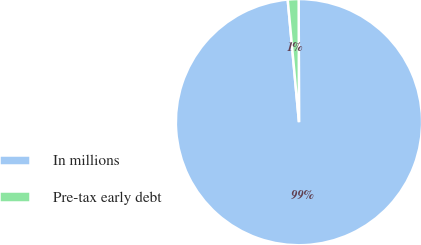Convert chart. <chart><loc_0><loc_0><loc_500><loc_500><pie_chart><fcel>In millions<fcel>Pre-tax early debt<nl><fcel>98.58%<fcel>1.42%<nl></chart> 